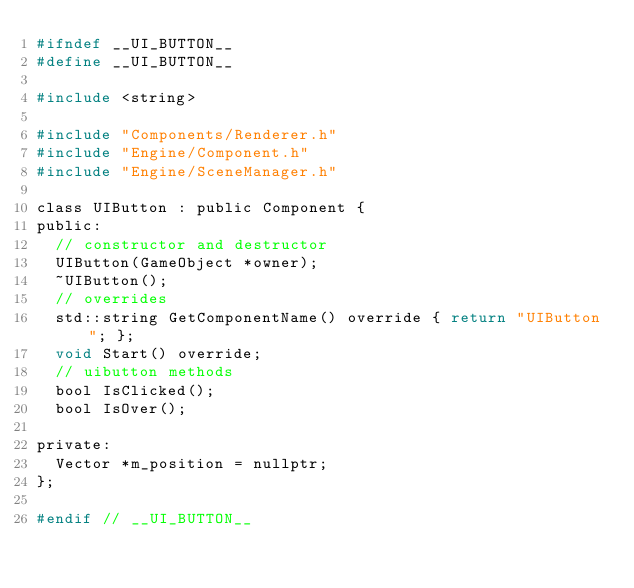Convert code to text. <code><loc_0><loc_0><loc_500><loc_500><_C_>#ifndef __UI_BUTTON__
#define __UI_BUTTON__

#include <string>

#include "Components/Renderer.h"
#include "Engine/Component.h"
#include "Engine/SceneManager.h"

class UIButton : public Component {
public:
  // constructor and destructor
  UIButton(GameObject *owner);
  ~UIButton();
  // overrides
  std::string GetComponentName() override { return "UIButton"; };
  void Start() override;
  // uibutton methods
  bool IsClicked();
  bool IsOver();

private:
  Vector *m_position = nullptr;
};

#endif // __UI_BUTTON__
</code> 